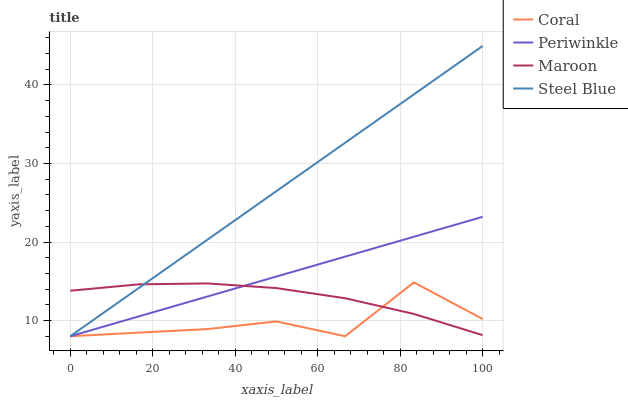Does Coral have the minimum area under the curve?
Answer yes or no. Yes. Does Steel Blue have the maximum area under the curve?
Answer yes or no. Yes. Does Periwinkle have the minimum area under the curve?
Answer yes or no. No. Does Periwinkle have the maximum area under the curve?
Answer yes or no. No. Is Periwinkle the smoothest?
Answer yes or no. Yes. Is Coral the roughest?
Answer yes or no. Yes. Is Steel Blue the smoothest?
Answer yes or no. No. Is Steel Blue the roughest?
Answer yes or no. No. Does Coral have the lowest value?
Answer yes or no. Yes. Does Maroon have the lowest value?
Answer yes or no. No. Does Steel Blue have the highest value?
Answer yes or no. Yes. Does Periwinkle have the highest value?
Answer yes or no. No. Does Maroon intersect Periwinkle?
Answer yes or no. Yes. Is Maroon less than Periwinkle?
Answer yes or no. No. Is Maroon greater than Periwinkle?
Answer yes or no. No. 